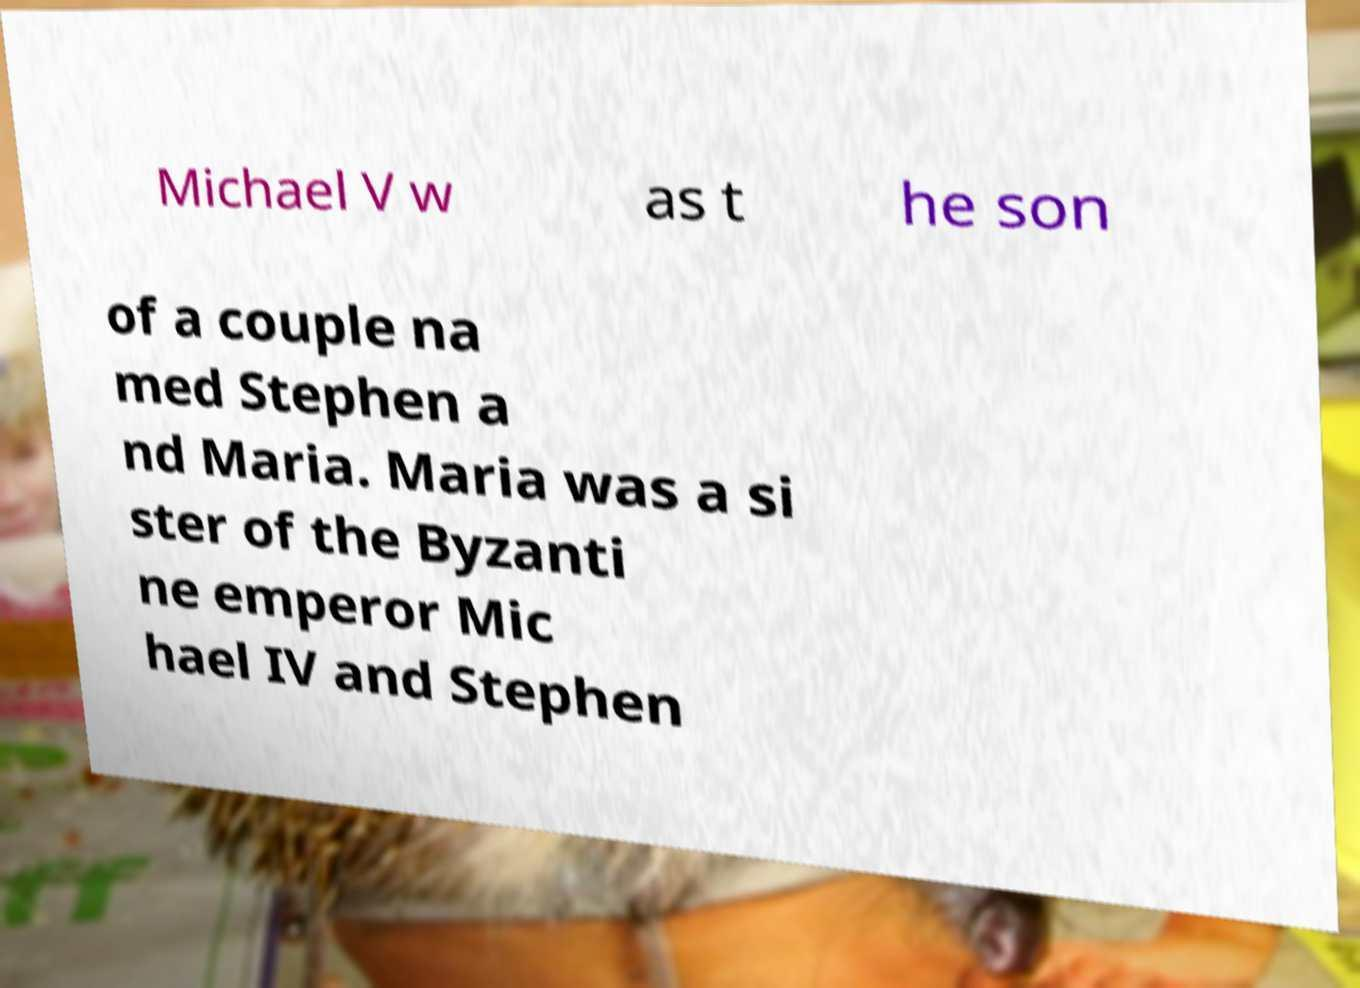Could you assist in decoding the text presented in this image and type it out clearly? Michael V w as t he son of a couple na med Stephen a nd Maria. Maria was a si ster of the Byzanti ne emperor Mic hael IV and Stephen 